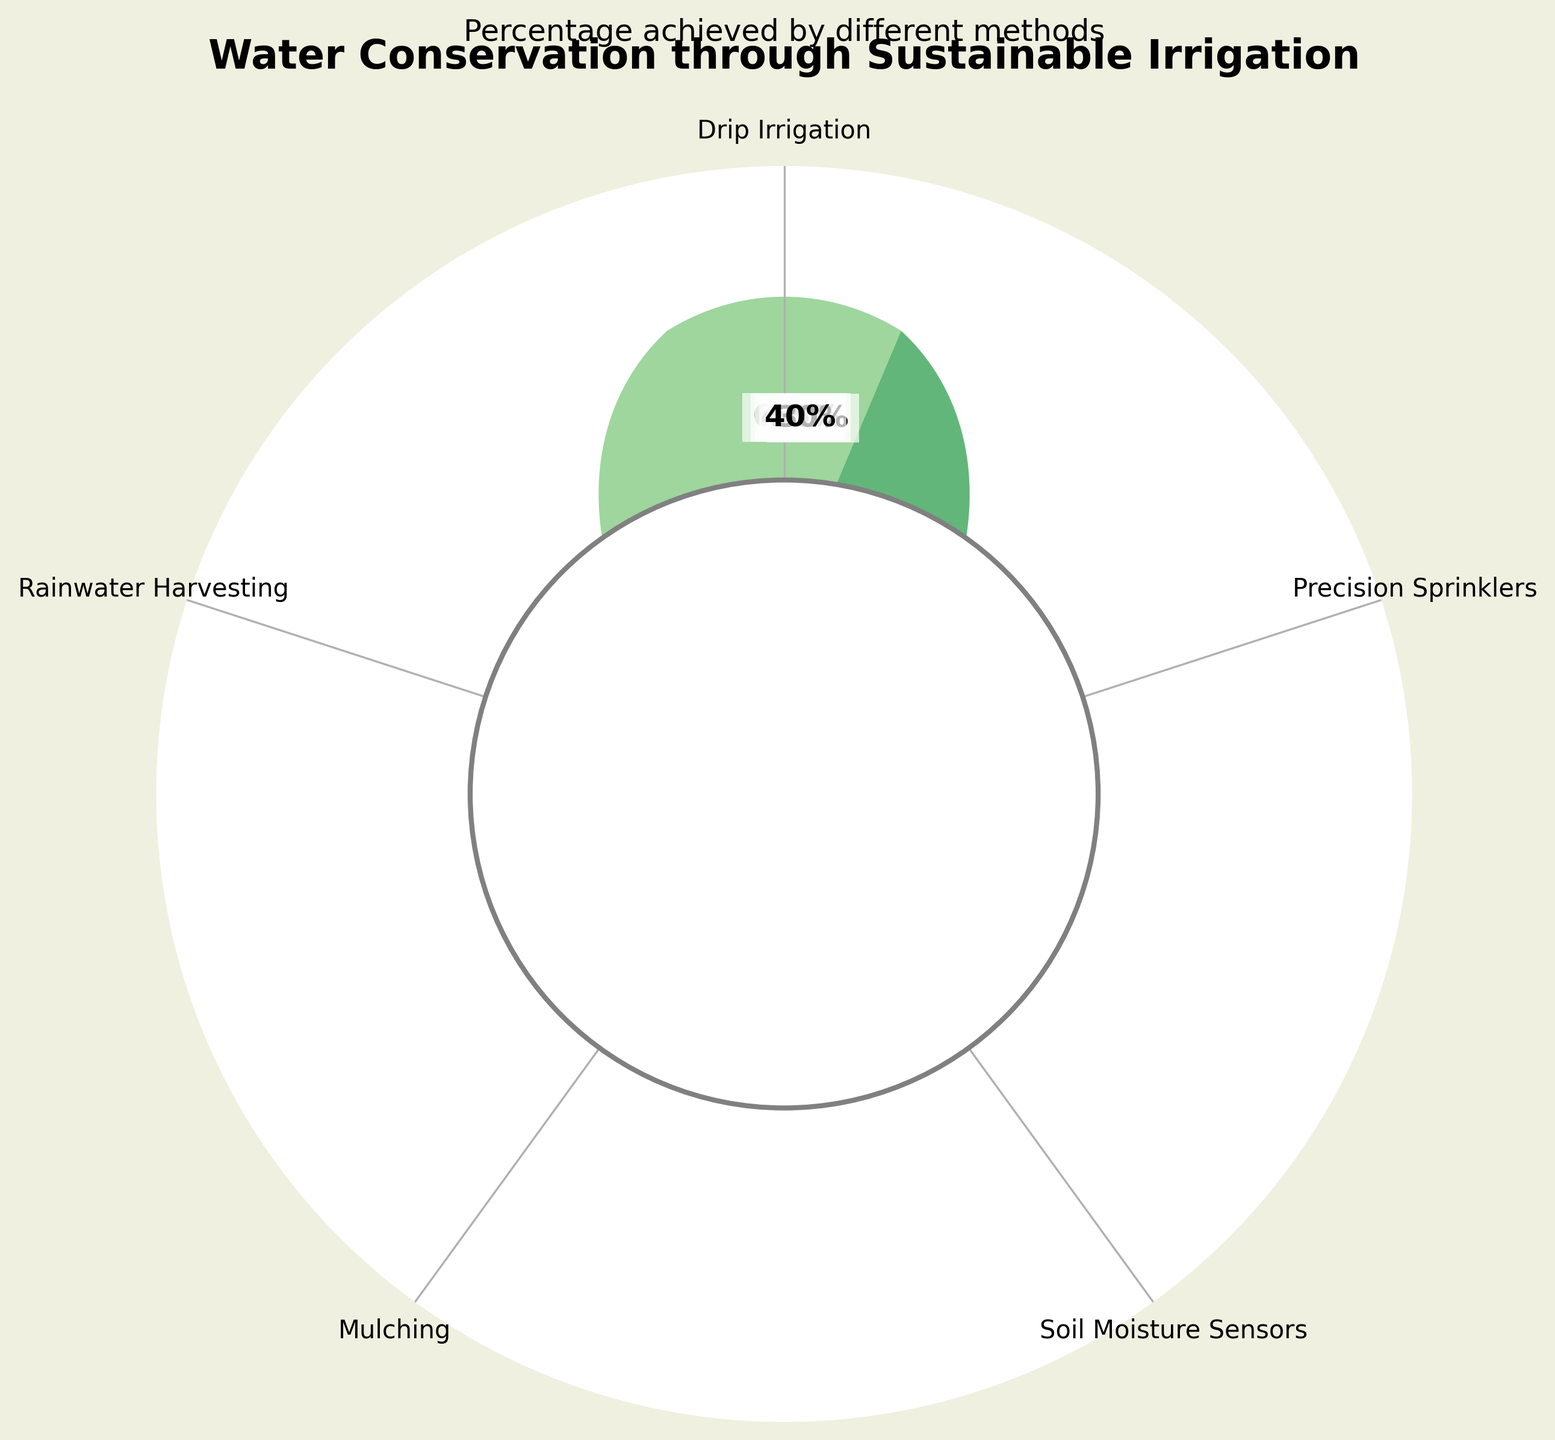How many different types of sustainable irrigation methods are shown in the figure? The figure includes labels for each type of sustainable irrigation method. Counting these labels will give the number of different types of methods presented.
Answer: 5 What is the title of the figure? The title is usually displayed at the top of the figure, prominently written for easy identification. It summarizes the main topic of the figure.
Answer: Water Conservation through Sustainable Irrigation Which irrigation method achieves the highest percentage of water conservation? By examining the wedges and their associated percentages listed on the figure, the irrigation method with the highest percentage can be identified.
Answer: Drip Irrigation Compare Drip Irrigation and Mulching. How much higher in percentage is Drip Irrigation compared to Mulching? Find the percentage values for Drip Irrigation (65%) and Mulching (30%) from the figure, then subtract the Mulching percentage from the Drip Irrigation percentage.
Answer: 35% What is the average percentage of water conservation achieved by all shown methods? Add the percentage values of all methods: (65 + 45 + 55 + 30 + 40). Then divide the total by the number of methods (5) to find the average.
Answer: 47% Which method has a percentage of water conservation closest to the average value? Calculate the average percentage (47%). Compare each method's percentage value to 47% and identify which one is closest to it.
Answer: Soil Moisture Sensors Rank the irrigation methods from highest to lowest based on their water conservation percentages. By examining the percentages provided for each method, list them in descending order of their values.
Answer: Drip Irrigation, Soil Moisture Sensors, Precision Sprinklers, Rainwater Harvesting, Mulching Identify an irrigation method that achieves less than 50% water conservation. Look for methods in the figure whose percentage values are below 50%. There are multiple possible answers; list at least one.
Answer: Precision Sprinklers or Mulching or Rainwater Harvesting If the average percentage of water conservation is 47%, how many methods exceed this average? Identify and count the number of methods whose water conservation percentages are higher than 47%.
Answer: 2 methods What color scheme is used to represent higher percentages of water conservation in the figure? Examine the color gradients in the figure, noting how colors change from low to high percentages. Usually, higher percentages will have more intense or darker shades.
Answer: Darker shades of green 